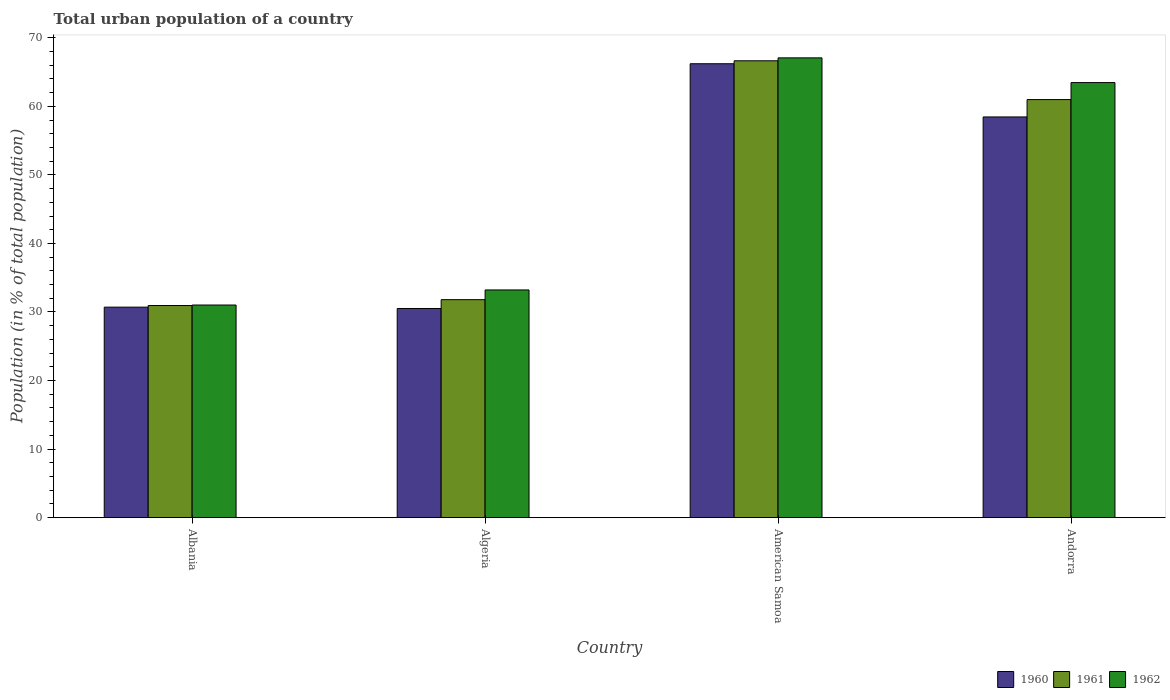How many groups of bars are there?
Keep it short and to the point. 4. Are the number of bars on each tick of the X-axis equal?
Provide a succinct answer. Yes. How many bars are there on the 4th tick from the left?
Offer a terse response. 3. What is the label of the 1st group of bars from the left?
Provide a succinct answer. Albania. In how many cases, is the number of bars for a given country not equal to the number of legend labels?
Keep it short and to the point. 0. What is the urban population in 1960 in American Samoa?
Provide a succinct answer. 66.21. Across all countries, what is the maximum urban population in 1961?
Provide a short and direct response. 66.64. Across all countries, what is the minimum urban population in 1960?
Your answer should be compact. 30.51. In which country was the urban population in 1960 maximum?
Provide a short and direct response. American Samoa. In which country was the urban population in 1961 minimum?
Your answer should be compact. Albania. What is the total urban population in 1960 in the graph?
Give a very brief answer. 185.88. What is the difference between the urban population in 1961 in Albania and that in American Samoa?
Offer a terse response. -35.7. What is the difference between the urban population in 1962 in Algeria and the urban population in 1961 in American Samoa?
Your response must be concise. -33.43. What is the average urban population in 1961 per country?
Give a very brief answer. 47.59. What is the difference between the urban population of/in 1960 and urban population of/in 1962 in Albania?
Make the answer very short. -0.31. In how many countries, is the urban population in 1960 greater than 32 %?
Make the answer very short. 2. What is the ratio of the urban population in 1961 in Albania to that in American Samoa?
Offer a terse response. 0.46. Is the difference between the urban population in 1960 in Albania and Algeria greater than the difference between the urban population in 1962 in Albania and Algeria?
Provide a succinct answer. Yes. What is the difference between the highest and the second highest urban population in 1960?
Offer a terse response. 7.76. What is the difference between the highest and the lowest urban population in 1961?
Provide a short and direct response. 35.7. Is the sum of the urban population in 1960 in American Samoa and Andorra greater than the maximum urban population in 1962 across all countries?
Your answer should be very brief. Yes. What does the 2nd bar from the right in Algeria represents?
Give a very brief answer. 1961. Is it the case that in every country, the sum of the urban population in 1962 and urban population in 1961 is greater than the urban population in 1960?
Your response must be concise. Yes. Are all the bars in the graph horizontal?
Offer a very short reply. No. What is the difference between two consecutive major ticks on the Y-axis?
Offer a very short reply. 10. Are the values on the major ticks of Y-axis written in scientific E-notation?
Offer a terse response. No. Does the graph contain grids?
Keep it short and to the point. No. Where does the legend appear in the graph?
Offer a very short reply. Bottom right. How many legend labels are there?
Provide a succinct answer. 3. How are the legend labels stacked?
Your answer should be compact. Horizontal. What is the title of the graph?
Make the answer very short. Total urban population of a country. What is the label or title of the Y-axis?
Your response must be concise. Population (in % of total population). What is the Population (in % of total population) of 1960 in Albania?
Ensure brevity in your answer.  30.7. What is the Population (in % of total population) of 1961 in Albania?
Ensure brevity in your answer.  30.94. What is the Population (in % of total population) in 1962 in Albania?
Give a very brief answer. 31.02. What is the Population (in % of total population) in 1960 in Algeria?
Your answer should be compact. 30.51. What is the Population (in % of total population) in 1961 in Algeria?
Offer a terse response. 31.8. What is the Population (in % of total population) of 1962 in Algeria?
Provide a short and direct response. 33.21. What is the Population (in % of total population) of 1960 in American Samoa?
Provide a succinct answer. 66.21. What is the Population (in % of total population) of 1961 in American Samoa?
Provide a short and direct response. 66.64. What is the Population (in % of total population) in 1962 in American Samoa?
Provide a succinct answer. 67.07. What is the Population (in % of total population) in 1960 in Andorra?
Your answer should be very brief. 58.45. What is the Population (in % of total population) of 1961 in Andorra?
Ensure brevity in your answer.  60.98. What is the Population (in % of total population) of 1962 in Andorra?
Keep it short and to the point. 63.46. Across all countries, what is the maximum Population (in % of total population) of 1960?
Your answer should be very brief. 66.21. Across all countries, what is the maximum Population (in % of total population) in 1961?
Your response must be concise. 66.64. Across all countries, what is the maximum Population (in % of total population) of 1962?
Give a very brief answer. 67.07. Across all countries, what is the minimum Population (in % of total population) of 1960?
Offer a terse response. 30.51. Across all countries, what is the minimum Population (in % of total population) in 1961?
Offer a very short reply. 30.94. Across all countries, what is the minimum Population (in % of total population) of 1962?
Give a very brief answer. 31.02. What is the total Population (in % of total population) in 1960 in the graph?
Your answer should be very brief. 185.88. What is the total Population (in % of total population) in 1961 in the graph?
Make the answer very short. 190.36. What is the total Population (in % of total population) in 1962 in the graph?
Offer a very short reply. 194.76. What is the difference between the Population (in % of total population) in 1960 in Albania and that in Algeria?
Provide a succinct answer. 0.2. What is the difference between the Population (in % of total population) in 1961 in Albania and that in Algeria?
Your response must be concise. -0.85. What is the difference between the Population (in % of total population) of 1962 in Albania and that in Algeria?
Your response must be concise. -2.2. What is the difference between the Population (in % of total population) of 1960 in Albania and that in American Samoa?
Offer a very short reply. -35.51. What is the difference between the Population (in % of total population) in 1961 in Albania and that in American Samoa?
Your response must be concise. -35.7. What is the difference between the Population (in % of total population) in 1962 in Albania and that in American Samoa?
Your response must be concise. -36.05. What is the difference between the Population (in % of total population) of 1960 in Albania and that in Andorra?
Your answer should be compact. -27.75. What is the difference between the Population (in % of total population) of 1961 in Albania and that in Andorra?
Your answer should be very brief. -30.04. What is the difference between the Population (in % of total population) in 1962 in Albania and that in Andorra?
Ensure brevity in your answer.  -32.45. What is the difference between the Population (in % of total population) of 1960 in Algeria and that in American Samoa?
Ensure brevity in your answer.  -35.7. What is the difference between the Population (in % of total population) in 1961 in Algeria and that in American Samoa?
Keep it short and to the point. -34.84. What is the difference between the Population (in % of total population) in 1962 in Algeria and that in American Samoa?
Your answer should be very brief. -33.85. What is the difference between the Population (in % of total population) in 1960 in Algeria and that in Andorra?
Your answer should be compact. -27.94. What is the difference between the Population (in % of total population) in 1961 in Algeria and that in Andorra?
Give a very brief answer. -29.19. What is the difference between the Population (in % of total population) of 1962 in Algeria and that in Andorra?
Your answer should be very brief. -30.25. What is the difference between the Population (in % of total population) in 1960 in American Samoa and that in Andorra?
Your answer should be very brief. 7.76. What is the difference between the Population (in % of total population) in 1961 in American Samoa and that in Andorra?
Provide a short and direct response. 5.66. What is the difference between the Population (in % of total population) of 1962 in American Samoa and that in Andorra?
Make the answer very short. 3.61. What is the difference between the Population (in % of total population) of 1960 in Albania and the Population (in % of total population) of 1961 in Algeria?
Offer a very short reply. -1.09. What is the difference between the Population (in % of total population) in 1960 in Albania and the Population (in % of total population) in 1962 in Algeria?
Ensure brevity in your answer.  -2.51. What is the difference between the Population (in % of total population) of 1961 in Albania and the Population (in % of total population) of 1962 in Algeria?
Offer a terse response. -2.27. What is the difference between the Population (in % of total population) in 1960 in Albania and the Population (in % of total population) in 1961 in American Samoa?
Keep it short and to the point. -35.94. What is the difference between the Population (in % of total population) in 1960 in Albania and the Population (in % of total population) in 1962 in American Samoa?
Provide a succinct answer. -36.36. What is the difference between the Population (in % of total population) of 1961 in Albania and the Population (in % of total population) of 1962 in American Samoa?
Your answer should be compact. -36.12. What is the difference between the Population (in % of total population) of 1960 in Albania and the Population (in % of total population) of 1961 in Andorra?
Make the answer very short. -30.28. What is the difference between the Population (in % of total population) of 1960 in Albania and the Population (in % of total population) of 1962 in Andorra?
Provide a succinct answer. -32.76. What is the difference between the Population (in % of total population) in 1961 in Albania and the Population (in % of total population) in 1962 in Andorra?
Your answer should be compact. -32.52. What is the difference between the Population (in % of total population) of 1960 in Algeria and the Population (in % of total population) of 1961 in American Samoa?
Your response must be concise. -36.13. What is the difference between the Population (in % of total population) in 1960 in Algeria and the Population (in % of total population) in 1962 in American Samoa?
Give a very brief answer. -36.56. What is the difference between the Population (in % of total population) of 1961 in Algeria and the Population (in % of total population) of 1962 in American Samoa?
Ensure brevity in your answer.  -35.27. What is the difference between the Population (in % of total population) of 1960 in Algeria and the Population (in % of total population) of 1961 in Andorra?
Provide a succinct answer. -30.47. What is the difference between the Population (in % of total population) of 1960 in Algeria and the Population (in % of total population) of 1962 in Andorra?
Your answer should be very brief. -32.95. What is the difference between the Population (in % of total population) of 1961 in Algeria and the Population (in % of total population) of 1962 in Andorra?
Your answer should be compact. -31.66. What is the difference between the Population (in % of total population) in 1960 in American Samoa and the Population (in % of total population) in 1961 in Andorra?
Your response must be concise. 5.23. What is the difference between the Population (in % of total population) of 1960 in American Samoa and the Population (in % of total population) of 1962 in Andorra?
Provide a succinct answer. 2.75. What is the difference between the Population (in % of total population) in 1961 in American Samoa and the Population (in % of total population) in 1962 in Andorra?
Provide a succinct answer. 3.18. What is the average Population (in % of total population) of 1960 per country?
Your response must be concise. 46.47. What is the average Population (in % of total population) in 1961 per country?
Your answer should be very brief. 47.59. What is the average Population (in % of total population) of 1962 per country?
Offer a very short reply. 48.69. What is the difference between the Population (in % of total population) in 1960 and Population (in % of total population) in 1961 in Albania?
Offer a terse response. -0.24. What is the difference between the Population (in % of total population) in 1960 and Population (in % of total population) in 1962 in Albania?
Offer a very short reply. -0.31. What is the difference between the Population (in % of total population) of 1961 and Population (in % of total population) of 1962 in Albania?
Keep it short and to the point. -0.07. What is the difference between the Population (in % of total population) in 1960 and Population (in % of total population) in 1961 in Algeria?
Give a very brief answer. -1.29. What is the difference between the Population (in % of total population) in 1960 and Population (in % of total population) in 1962 in Algeria?
Provide a short and direct response. -2.7. What is the difference between the Population (in % of total population) in 1961 and Population (in % of total population) in 1962 in Algeria?
Provide a succinct answer. -1.42. What is the difference between the Population (in % of total population) of 1960 and Population (in % of total population) of 1961 in American Samoa?
Ensure brevity in your answer.  -0.43. What is the difference between the Population (in % of total population) of 1960 and Population (in % of total population) of 1962 in American Samoa?
Offer a very short reply. -0.86. What is the difference between the Population (in % of total population) in 1961 and Population (in % of total population) in 1962 in American Samoa?
Provide a succinct answer. -0.43. What is the difference between the Population (in % of total population) of 1960 and Population (in % of total population) of 1961 in Andorra?
Offer a very short reply. -2.53. What is the difference between the Population (in % of total population) in 1960 and Population (in % of total population) in 1962 in Andorra?
Keep it short and to the point. -5.01. What is the difference between the Population (in % of total population) in 1961 and Population (in % of total population) in 1962 in Andorra?
Provide a succinct answer. -2.48. What is the ratio of the Population (in % of total population) of 1960 in Albania to that in Algeria?
Offer a terse response. 1.01. What is the ratio of the Population (in % of total population) of 1961 in Albania to that in Algeria?
Give a very brief answer. 0.97. What is the ratio of the Population (in % of total population) of 1962 in Albania to that in Algeria?
Keep it short and to the point. 0.93. What is the ratio of the Population (in % of total population) of 1960 in Albania to that in American Samoa?
Give a very brief answer. 0.46. What is the ratio of the Population (in % of total population) in 1961 in Albania to that in American Samoa?
Your response must be concise. 0.46. What is the ratio of the Population (in % of total population) of 1962 in Albania to that in American Samoa?
Provide a short and direct response. 0.46. What is the ratio of the Population (in % of total population) of 1960 in Albania to that in Andorra?
Provide a short and direct response. 0.53. What is the ratio of the Population (in % of total population) in 1961 in Albania to that in Andorra?
Offer a terse response. 0.51. What is the ratio of the Population (in % of total population) of 1962 in Albania to that in Andorra?
Your answer should be compact. 0.49. What is the ratio of the Population (in % of total population) in 1960 in Algeria to that in American Samoa?
Your response must be concise. 0.46. What is the ratio of the Population (in % of total population) of 1961 in Algeria to that in American Samoa?
Offer a terse response. 0.48. What is the ratio of the Population (in % of total population) in 1962 in Algeria to that in American Samoa?
Your answer should be compact. 0.5. What is the ratio of the Population (in % of total population) of 1960 in Algeria to that in Andorra?
Offer a very short reply. 0.52. What is the ratio of the Population (in % of total population) of 1961 in Algeria to that in Andorra?
Give a very brief answer. 0.52. What is the ratio of the Population (in % of total population) in 1962 in Algeria to that in Andorra?
Your answer should be compact. 0.52. What is the ratio of the Population (in % of total population) in 1960 in American Samoa to that in Andorra?
Your answer should be compact. 1.13. What is the ratio of the Population (in % of total population) of 1961 in American Samoa to that in Andorra?
Provide a succinct answer. 1.09. What is the ratio of the Population (in % of total population) in 1962 in American Samoa to that in Andorra?
Ensure brevity in your answer.  1.06. What is the difference between the highest and the second highest Population (in % of total population) of 1960?
Your answer should be very brief. 7.76. What is the difference between the highest and the second highest Population (in % of total population) in 1961?
Your response must be concise. 5.66. What is the difference between the highest and the second highest Population (in % of total population) of 1962?
Keep it short and to the point. 3.61. What is the difference between the highest and the lowest Population (in % of total population) of 1960?
Make the answer very short. 35.7. What is the difference between the highest and the lowest Population (in % of total population) in 1961?
Make the answer very short. 35.7. What is the difference between the highest and the lowest Population (in % of total population) in 1962?
Your response must be concise. 36.05. 